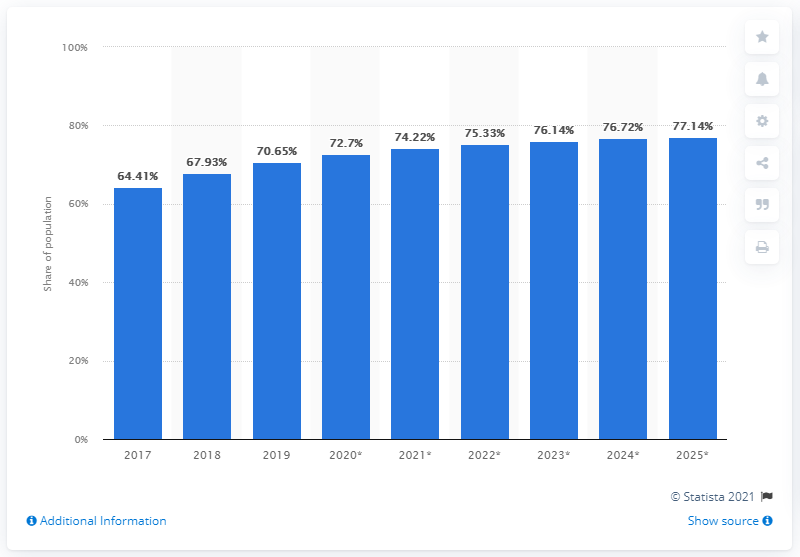Specify some key components in this picture. By 2025, it is projected that over 77% of the population will be using the internet. In 2019, approximately 70.65% of the population in the Philippines used the internet, representing a significant increase from previous years. 